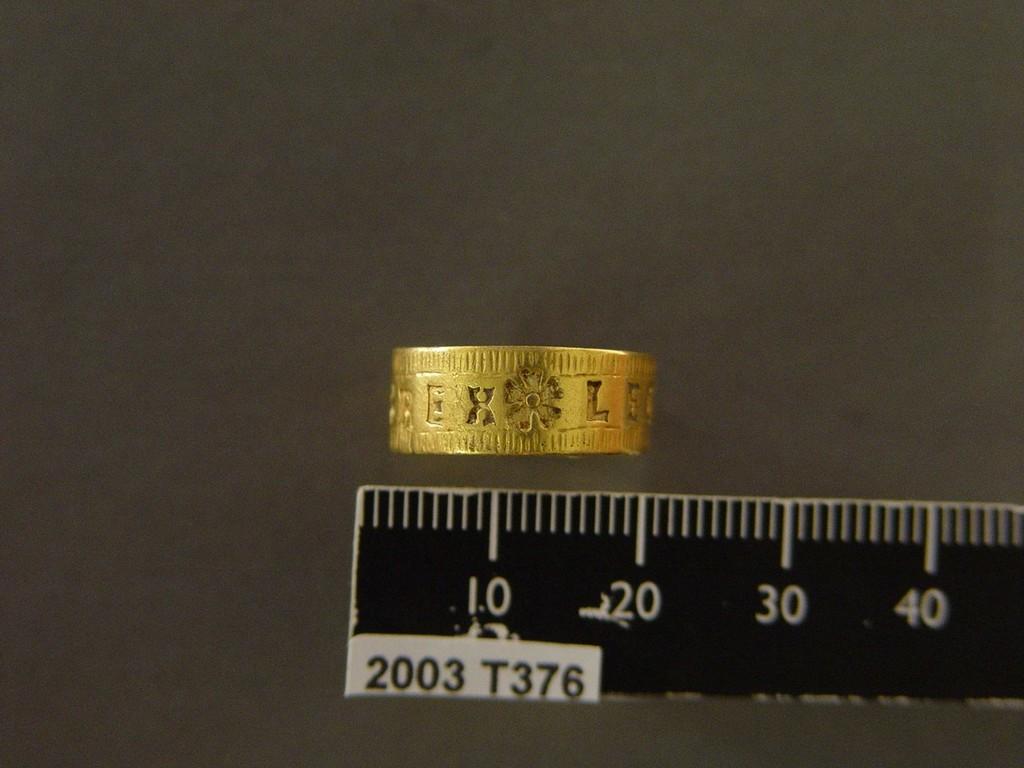What year is this taken?
Make the answer very short. 2003. What is the left number?
Provide a short and direct response. 10. 